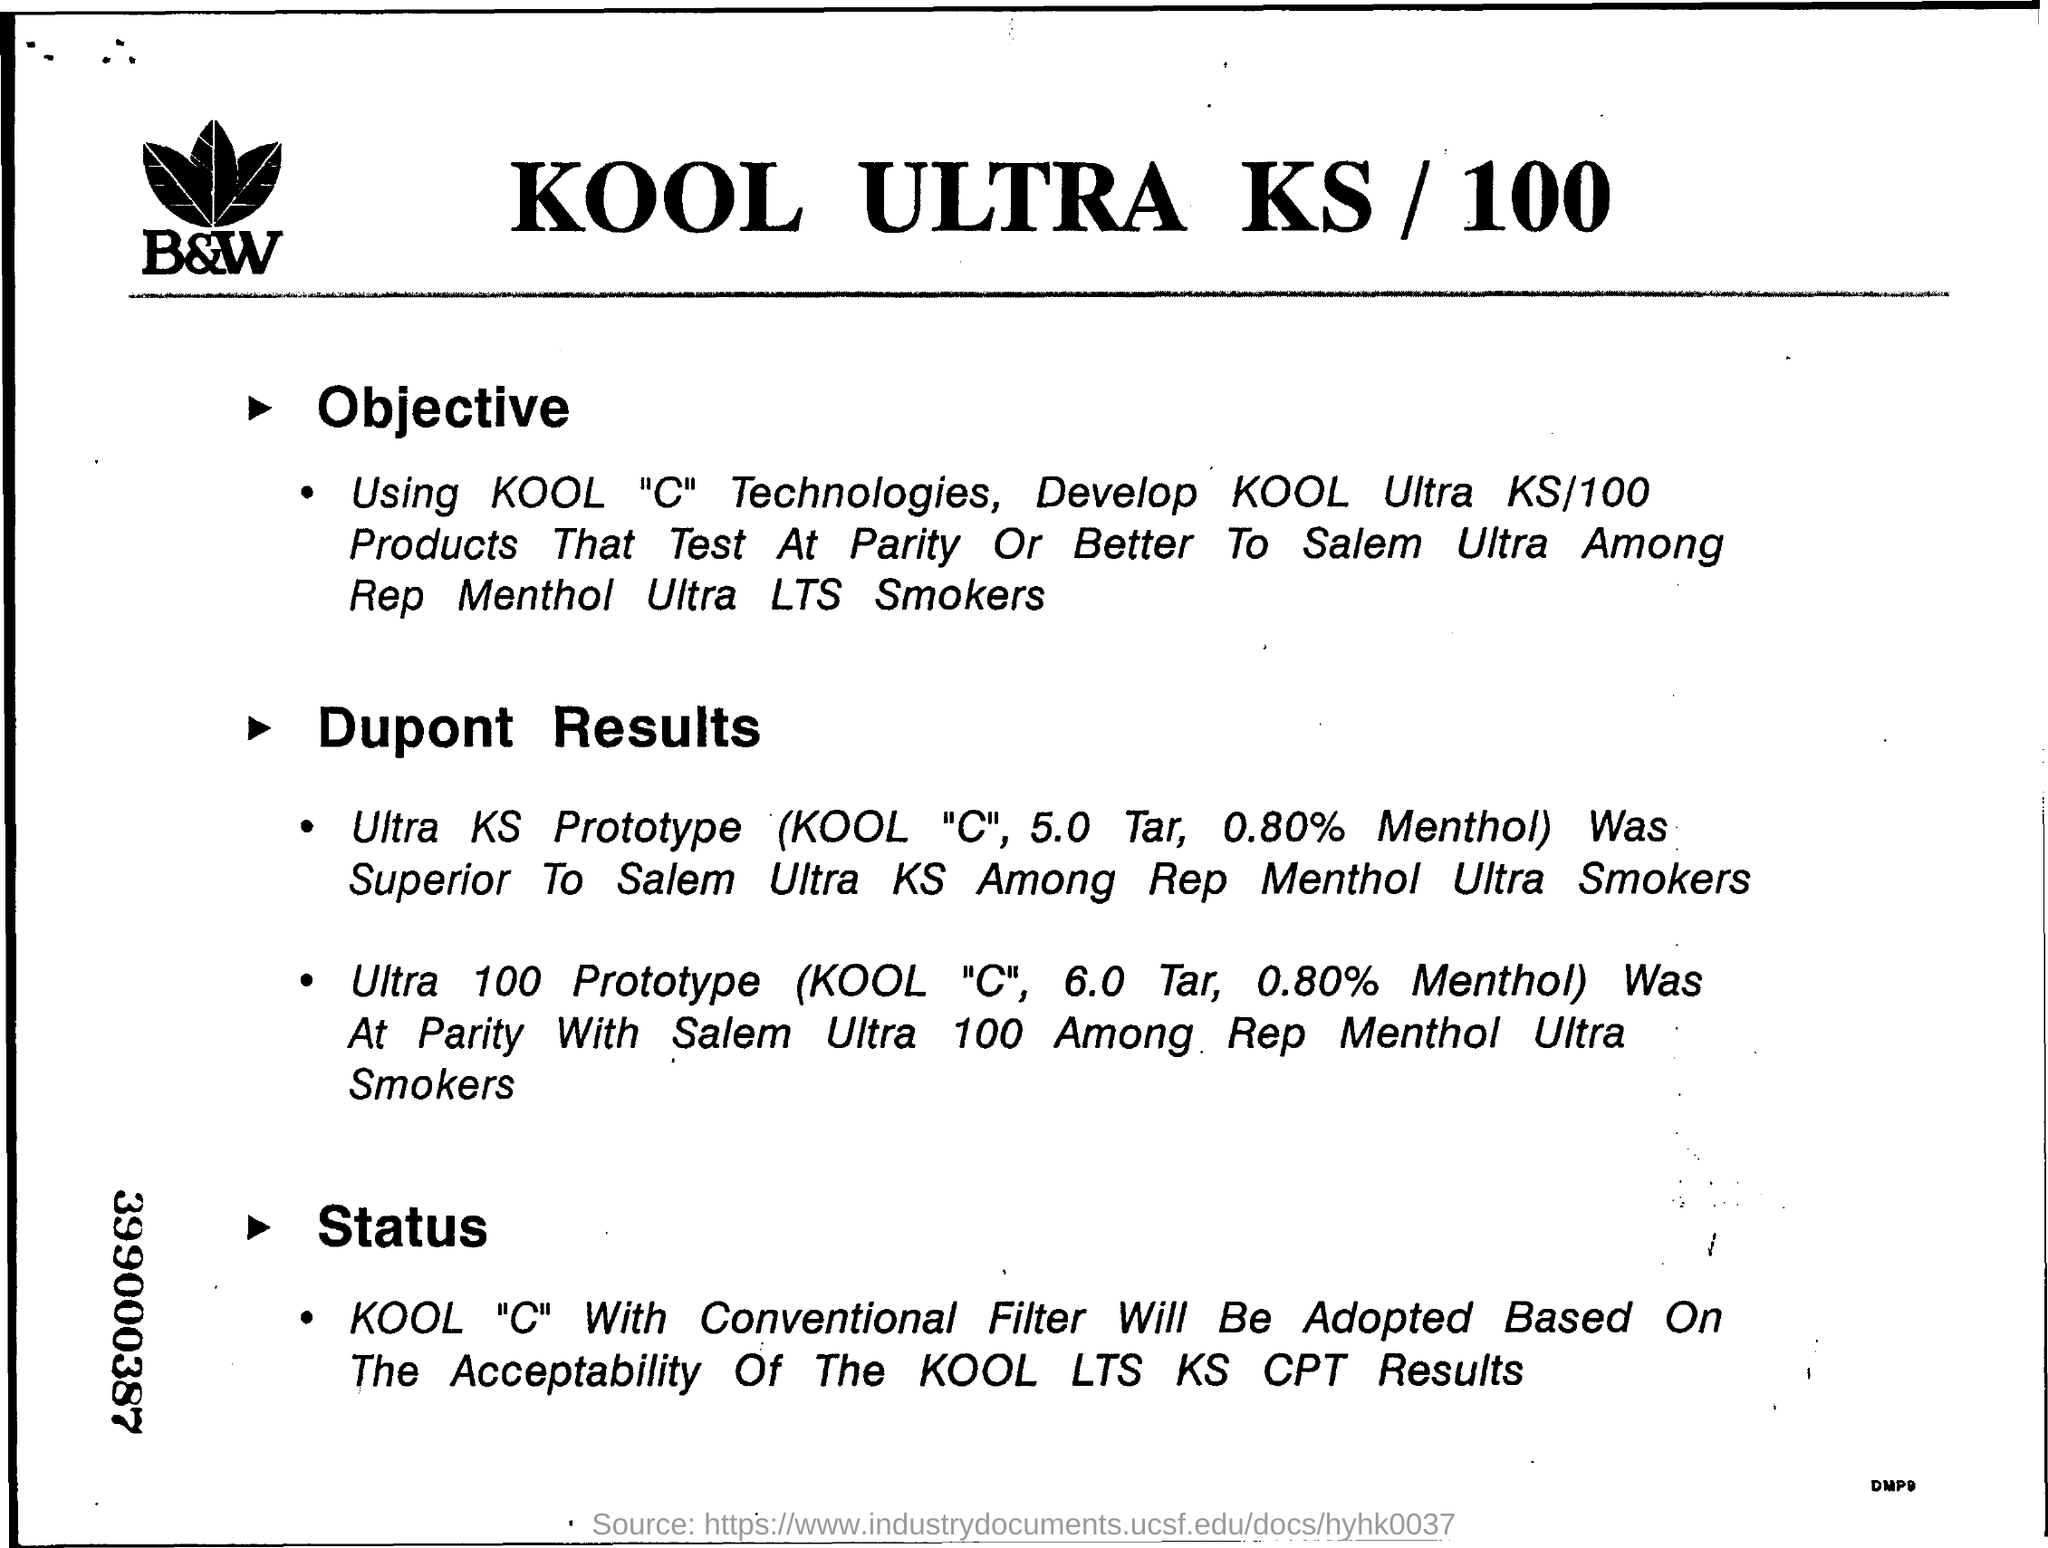Identify some key points in this picture. The KOOL "C" air conditioner with a conventional filter will be adopted based on the acceptability of the KOOL Long-Term Stress (LTS) and Cooling Peak Test (CPT) results. The Ultra KS Prototype is considered superior to the Salem Ultra 100 among regular menthol smokers. The title of the document is "KOOL ULTRA KS / 100. 